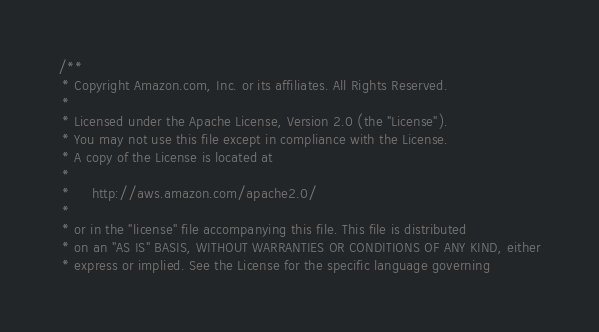Convert code to text. <code><loc_0><loc_0><loc_500><loc_500><_C++_>/**
 * Copyright Amazon.com, Inc. or its affiliates. All Rights Reserved.
 *
 * Licensed under the Apache License, Version 2.0 (the "License").
 * You may not use this file except in compliance with the License.
 * A copy of the License is located at
 *
 *     http://aws.amazon.com/apache2.0/
 *
 * or in the "license" file accompanying this file. This file is distributed
 * on an "AS IS" BASIS, WITHOUT WARRANTIES OR CONDITIONS OF ANY KIND, either
 * express or implied. See the License for the specific language governing</code> 